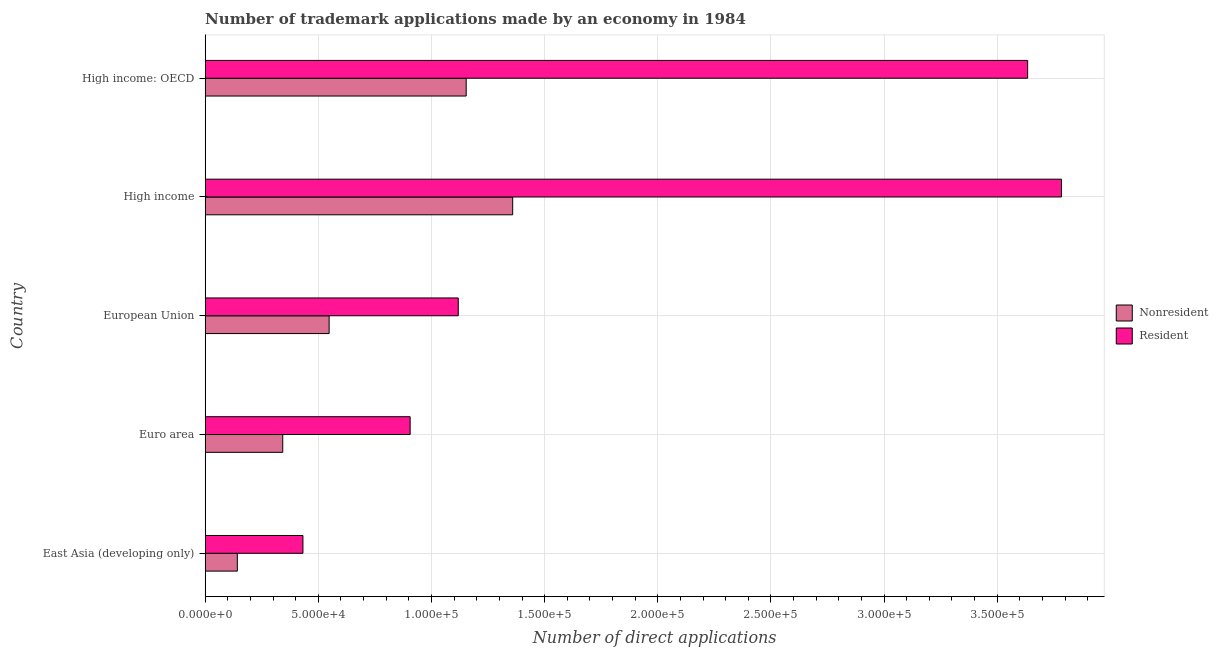How many different coloured bars are there?
Your answer should be very brief. 2. Are the number of bars per tick equal to the number of legend labels?
Provide a succinct answer. Yes. How many bars are there on the 5th tick from the top?
Make the answer very short. 2. How many bars are there on the 4th tick from the bottom?
Provide a short and direct response. 2. In how many cases, is the number of bars for a given country not equal to the number of legend labels?
Offer a terse response. 0. What is the number of trademark applications made by residents in High income?
Offer a very short reply. 3.78e+05. Across all countries, what is the maximum number of trademark applications made by non residents?
Your answer should be compact. 1.36e+05. Across all countries, what is the minimum number of trademark applications made by non residents?
Your answer should be compact. 1.42e+04. In which country was the number of trademark applications made by residents minimum?
Give a very brief answer. East Asia (developing only). What is the total number of trademark applications made by residents in the graph?
Make the answer very short. 9.87e+05. What is the difference between the number of trademark applications made by non residents in East Asia (developing only) and that in Euro area?
Make the answer very short. -2.01e+04. What is the difference between the number of trademark applications made by non residents in High income and the number of trademark applications made by residents in Euro area?
Provide a short and direct response. 4.53e+04. What is the average number of trademark applications made by non residents per country?
Give a very brief answer. 7.09e+04. What is the difference between the number of trademark applications made by residents and number of trademark applications made by non residents in East Asia (developing only)?
Provide a short and direct response. 2.90e+04. In how many countries, is the number of trademark applications made by non residents greater than 290000 ?
Give a very brief answer. 0. What is the ratio of the number of trademark applications made by non residents in East Asia (developing only) to that in High income?
Keep it short and to the point. 0.1. Is the number of trademark applications made by non residents in Euro area less than that in High income?
Keep it short and to the point. Yes. What is the difference between the highest and the second highest number of trademark applications made by residents?
Offer a very short reply. 1.49e+04. What is the difference between the highest and the lowest number of trademark applications made by residents?
Keep it short and to the point. 3.35e+05. In how many countries, is the number of trademark applications made by non residents greater than the average number of trademark applications made by non residents taken over all countries?
Provide a succinct answer. 2. Is the sum of the number of trademark applications made by residents in European Union and High income greater than the maximum number of trademark applications made by non residents across all countries?
Keep it short and to the point. Yes. What does the 2nd bar from the top in High income: OECD represents?
Your response must be concise. Nonresident. What does the 1st bar from the bottom in East Asia (developing only) represents?
Ensure brevity in your answer.  Nonresident. Are all the bars in the graph horizontal?
Your answer should be compact. Yes. What is the difference between two consecutive major ticks on the X-axis?
Offer a terse response. 5.00e+04. Are the values on the major ticks of X-axis written in scientific E-notation?
Make the answer very short. Yes. Does the graph contain any zero values?
Offer a terse response. No. Does the graph contain grids?
Your response must be concise. Yes. How are the legend labels stacked?
Provide a short and direct response. Vertical. What is the title of the graph?
Give a very brief answer. Number of trademark applications made by an economy in 1984. What is the label or title of the X-axis?
Provide a succinct answer. Number of direct applications. What is the Number of direct applications in Nonresident in East Asia (developing only)?
Provide a succinct answer. 1.42e+04. What is the Number of direct applications in Resident in East Asia (developing only)?
Provide a succinct answer. 4.32e+04. What is the Number of direct applications in Nonresident in Euro area?
Provide a short and direct response. 3.43e+04. What is the Number of direct applications in Resident in Euro area?
Provide a short and direct response. 9.06e+04. What is the Number of direct applications in Nonresident in European Union?
Your response must be concise. 5.48e+04. What is the Number of direct applications of Resident in European Union?
Offer a terse response. 1.12e+05. What is the Number of direct applications of Nonresident in High income?
Offer a very short reply. 1.36e+05. What is the Number of direct applications of Resident in High income?
Keep it short and to the point. 3.78e+05. What is the Number of direct applications in Nonresident in High income: OECD?
Make the answer very short. 1.15e+05. What is the Number of direct applications in Resident in High income: OECD?
Provide a short and direct response. 3.63e+05. Across all countries, what is the maximum Number of direct applications in Nonresident?
Ensure brevity in your answer.  1.36e+05. Across all countries, what is the maximum Number of direct applications of Resident?
Offer a terse response. 3.78e+05. Across all countries, what is the minimum Number of direct applications in Nonresident?
Ensure brevity in your answer.  1.42e+04. Across all countries, what is the minimum Number of direct applications of Resident?
Ensure brevity in your answer.  4.32e+04. What is the total Number of direct applications in Nonresident in the graph?
Offer a very short reply. 3.54e+05. What is the total Number of direct applications of Resident in the graph?
Make the answer very short. 9.87e+05. What is the difference between the Number of direct applications of Nonresident in East Asia (developing only) and that in Euro area?
Ensure brevity in your answer.  -2.01e+04. What is the difference between the Number of direct applications in Resident in East Asia (developing only) and that in Euro area?
Your answer should be very brief. -4.74e+04. What is the difference between the Number of direct applications in Nonresident in East Asia (developing only) and that in European Union?
Give a very brief answer. -4.06e+04. What is the difference between the Number of direct applications in Resident in East Asia (developing only) and that in European Union?
Give a very brief answer. -6.86e+04. What is the difference between the Number of direct applications of Nonresident in East Asia (developing only) and that in High income?
Your answer should be very brief. -1.22e+05. What is the difference between the Number of direct applications in Resident in East Asia (developing only) and that in High income?
Provide a short and direct response. -3.35e+05. What is the difference between the Number of direct applications in Nonresident in East Asia (developing only) and that in High income: OECD?
Make the answer very short. -1.01e+05. What is the difference between the Number of direct applications of Resident in East Asia (developing only) and that in High income: OECD?
Ensure brevity in your answer.  -3.20e+05. What is the difference between the Number of direct applications of Nonresident in Euro area and that in European Union?
Ensure brevity in your answer.  -2.05e+04. What is the difference between the Number of direct applications of Resident in Euro area and that in European Union?
Offer a very short reply. -2.13e+04. What is the difference between the Number of direct applications of Nonresident in Euro area and that in High income?
Keep it short and to the point. -1.02e+05. What is the difference between the Number of direct applications in Resident in Euro area and that in High income?
Keep it short and to the point. -2.88e+05. What is the difference between the Number of direct applications of Nonresident in Euro area and that in High income: OECD?
Keep it short and to the point. -8.11e+04. What is the difference between the Number of direct applications in Resident in Euro area and that in High income: OECD?
Make the answer very short. -2.73e+05. What is the difference between the Number of direct applications of Nonresident in European Union and that in High income?
Your answer should be compact. -8.11e+04. What is the difference between the Number of direct applications in Resident in European Union and that in High income?
Your answer should be very brief. -2.67e+05. What is the difference between the Number of direct applications of Nonresident in European Union and that in High income: OECD?
Provide a succinct answer. -6.06e+04. What is the difference between the Number of direct applications of Resident in European Union and that in High income: OECD?
Make the answer very short. -2.52e+05. What is the difference between the Number of direct applications of Nonresident in High income and that in High income: OECD?
Offer a very short reply. 2.05e+04. What is the difference between the Number of direct applications of Resident in High income and that in High income: OECD?
Your response must be concise. 1.49e+04. What is the difference between the Number of direct applications in Nonresident in East Asia (developing only) and the Number of direct applications in Resident in Euro area?
Offer a very short reply. -7.64e+04. What is the difference between the Number of direct applications of Nonresident in East Asia (developing only) and the Number of direct applications of Resident in European Union?
Your answer should be very brief. -9.76e+04. What is the difference between the Number of direct applications in Nonresident in East Asia (developing only) and the Number of direct applications in Resident in High income?
Give a very brief answer. -3.64e+05. What is the difference between the Number of direct applications in Nonresident in East Asia (developing only) and the Number of direct applications in Resident in High income: OECD?
Ensure brevity in your answer.  -3.49e+05. What is the difference between the Number of direct applications of Nonresident in Euro area and the Number of direct applications of Resident in European Union?
Provide a short and direct response. -7.76e+04. What is the difference between the Number of direct applications in Nonresident in Euro area and the Number of direct applications in Resident in High income?
Your answer should be compact. -3.44e+05. What is the difference between the Number of direct applications in Nonresident in Euro area and the Number of direct applications in Resident in High income: OECD?
Offer a terse response. -3.29e+05. What is the difference between the Number of direct applications in Nonresident in European Union and the Number of direct applications in Resident in High income?
Your response must be concise. -3.24e+05. What is the difference between the Number of direct applications in Nonresident in European Union and the Number of direct applications in Resident in High income: OECD?
Provide a succinct answer. -3.09e+05. What is the difference between the Number of direct applications in Nonresident in High income and the Number of direct applications in Resident in High income: OECD?
Provide a succinct answer. -2.28e+05. What is the average Number of direct applications of Nonresident per country?
Your answer should be compact. 7.09e+04. What is the average Number of direct applications in Resident per country?
Provide a short and direct response. 1.97e+05. What is the difference between the Number of direct applications of Nonresident and Number of direct applications of Resident in East Asia (developing only)?
Your answer should be compact. -2.90e+04. What is the difference between the Number of direct applications in Nonresident and Number of direct applications in Resident in Euro area?
Offer a very short reply. -5.63e+04. What is the difference between the Number of direct applications in Nonresident and Number of direct applications in Resident in European Union?
Keep it short and to the point. -5.71e+04. What is the difference between the Number of direct applications of Nonresident and Number of direct applications of Resident in High income?
Your answer should be compact. -2.42e+05. What is the difference between the Number of direct applications in Nonresident and Number of direct applications in Resident in High income: OECD?
Your response must be concise. -2.48e+05. What is the ratio of the Number of direct applications of Nonresident in East Asia (developing only) to that in Euro area?
Make the answer very short. 0.41. What is the ratio of the Number of direct applications in Resident in East Asia (developing only) to that in Euro area?
Your answer should be very brief. 0.48. What is the ratio of the Number of direct applications of Nonresident in East Asia (developing only) to that in European Union?
Provide a short and direct response. 0.26. What is the ratio of the Number of direct applications in Resident in East Asia (developing only) to that in European Union?
Your response must be concise. 0.39. What is the ratio of the Number of direct applications in Nonresident in East Asia (developing only) to that in High income?
Give a very brief answer. 0.1. What is the ratio of the Number of direct applications in Resident in East Asia (developing only) to that in High income?
Offer a terse response. 0.11. What is the ratio of the Number of direct applications in Nonresident in East Asia (developing only) to that in High income: OECD?
Make the answer very short. 0.12. What is the ratio of the Number of direct applications in Resident in East Asia (developing only) to that in High income: OECD?
Keep it short and to the point. 0.12. What is the ratio of the Number of direct applications of Nonresident in Euro area to that in European Union?
Offer a very short reply. 0.63. What is the ratio of the Number of direct applications of Resident in Euro area to that in European Union?
Provide a succinct answer. 0.81. What is the ratio of the Number of direct applications of Nonresident in Euro area to that in High income?
Your answer should be compact. 0.25. What is the ratio of the Number of direct applications in Resident in Euro area to that in High income?
Give a very brief answer. 0.24. What is the ratio of the Number of direct applications of Nonresident in Euro area to that in High income: OECD?
Ensure brevity in your answer.  0.3. What is the ratio of the Number of direct applications of Resident in Euro area to that in High income: OECD?
Your answer should be compact. 0.25. What is the ratio of the Number of direct applications of Nonresident in European Union to that in High income?
Offer a terse response. 0.4. What is the ratio of the Number of direct applications in Resident in European Union to that in High income?
Provide a short and direct response. 0.3. What is the ratio of the Number of direct applications in Nonresident in European Union to that in High income: OECD?
Offer a terse response. 0.47. What is the ratio of the Number of direct applications of Resident in European Union to that in High income: OECD?
Your answer should be very brief. 0.31. What is the ratio of the Number of direct applications in Nonresident in High income to that in High income: OECD?
Provide a succinct answer. 1.18. What is the ratio of the Number of direct applications in Resident in High income to that in High income: OECD?
Keep it short and to the point. 1.04. What is the difference between the highest and the second highest Number of direct applications of Nonresident?
Ensure brevity in your answer.  2.05e+04. What is the difference between the highest and the second highest Number of direct applications of Resident?
Provide a succinct answer. 1.49e+04. What is the difference between the highest and the lowest Number of direct applications of Nonresident?
Provide a short and direct response. 1.22e+05. What is the difference between the highest and the lowest Number of direct applications in Resident?
Provide a short and direct response. 3.35e+05. 